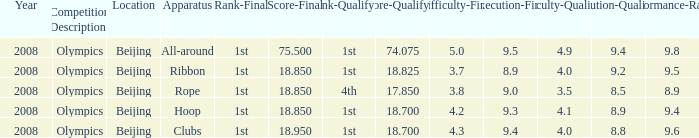On which apparatus did Kanayeva have a final score smaller than 75.5 and a qualifying score smaller than 18.7? Rope. 